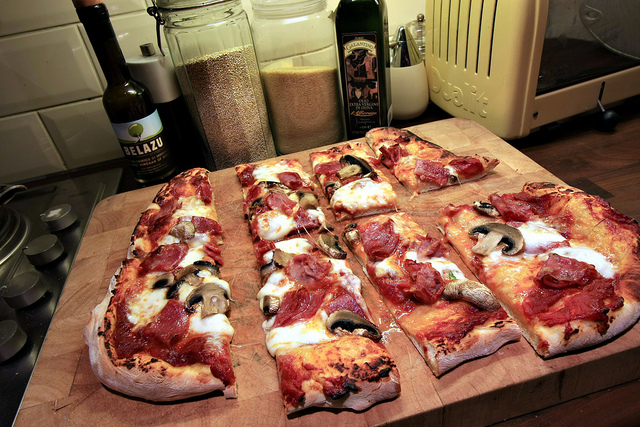Please identify all text content in this image. BELAZU 